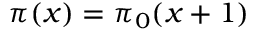Convert formula to latex. <formula><loc_0><loc_0><loc_500><loc_500>\pi ( x ) = \pi _ { 0 } ( x + 1 )</formula> 